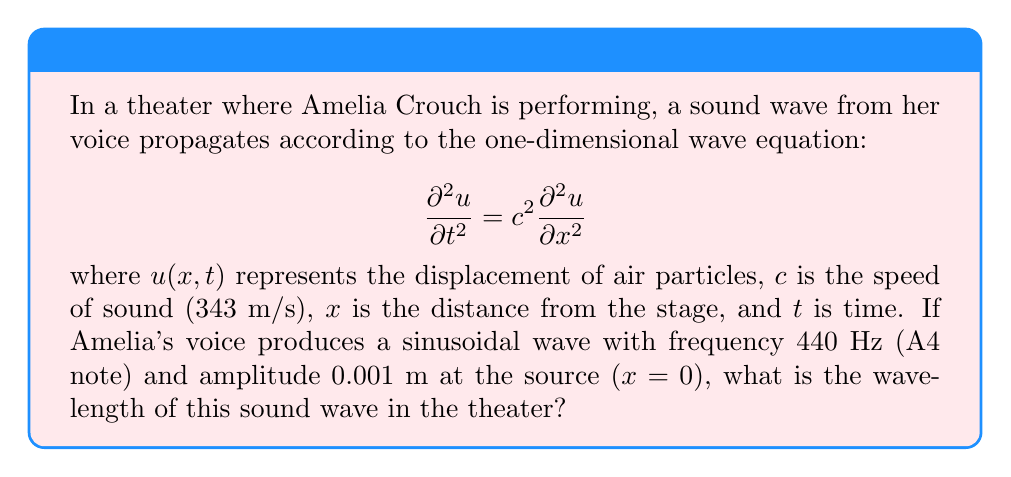Could you help me with this problem? To solve this problem, we'll follow these steps:

1) The general solution for a sinusoidal wave traveling in the positive x-direction is:

   $$u(x,t) = A \sin(kx - \omega t)$$

   where $A$ is the amplitude, $k$ is the wave number, and $\omega$ is the angular frequency.

2) We're given the frequency $f = 440$ Hz. The angular frequency $\omega$ is related to $f$ by:

   $$\omega = 2\pi f = 2\pi(440) \approx 2763.89 \text{ rad/s}$$

3) The wave number $k$ is related to the wavelength $\lambda$ by:

   $$k = \frac{2\pi}{\lambda}$$

4) For a wave equation $\frac{\partial^2 u}{\partial t^2} = c^2 \frac{\partial^2 u}{\partial x^2}$, the relationship between $\omega$, $k$, and $c$ is:

   $$\omega = ck$$

5) Substituting the expressions for $\omega$ and $k$:

   $$2\pi f = c \cdot \frac{2\pi}{\lambda}$$

6) Solving for $\lambda$:

   $$\lambda = \frac{c}{f} = \frac{343 \text{ m/s}}{440 \text{ Hz}} \approx 0.78 \text{ m}$$

Thus, the wavelength of Amelia's A4 note in the theater is approximately 0.78 meters.
Answer: 0.78 m 